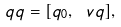<formula> <loc_0><loc_0><loc_500><loc_500>\ q q = [ q _ { 0 } , \ v q ] ,</formula> 